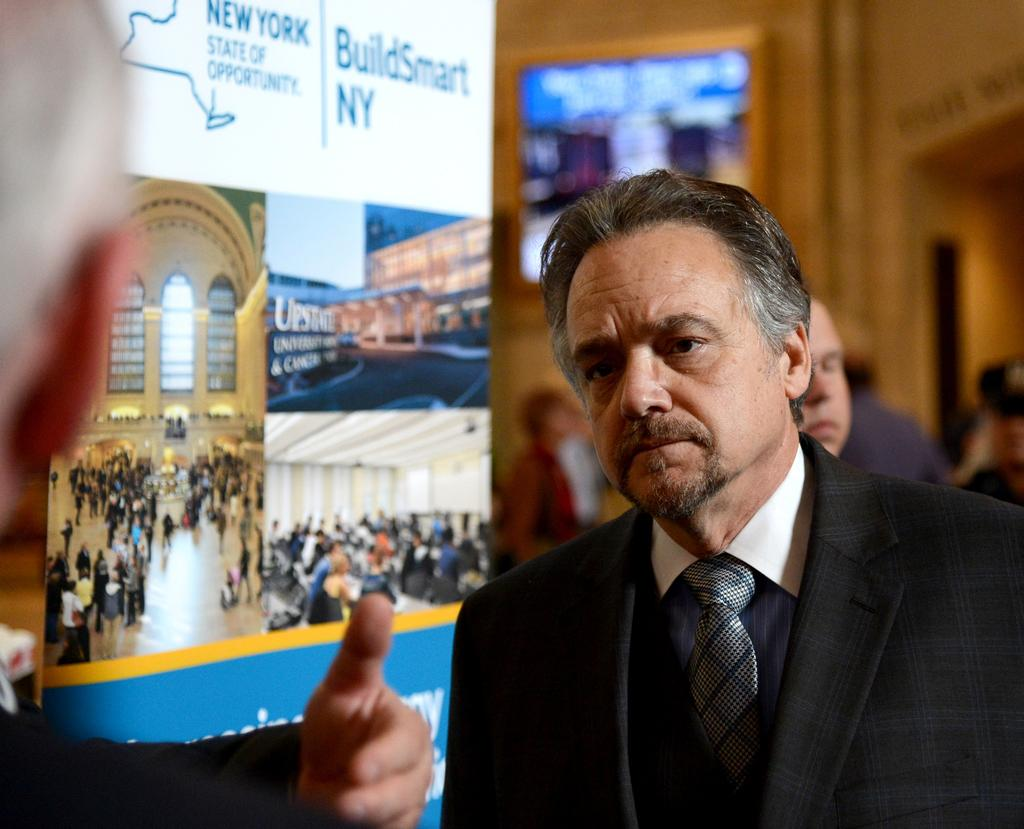Who or what is present in the image? There are people in the image. What is the board with pictures and text used for? The board with pictures and text is likely used for communication or displaying information. Can you describe the group of people on the backside of the image? There is a group of people on the backside of the image, but their specific characteristics cannot be determined from the provided facts. What is the frame on the wall used for? The frame on the wall is likely used for displaying artwork or photographs. What type of calendar is hanging on the wall in the image? There is no calendar present in the image; only a frame on a wall is mentioned. 